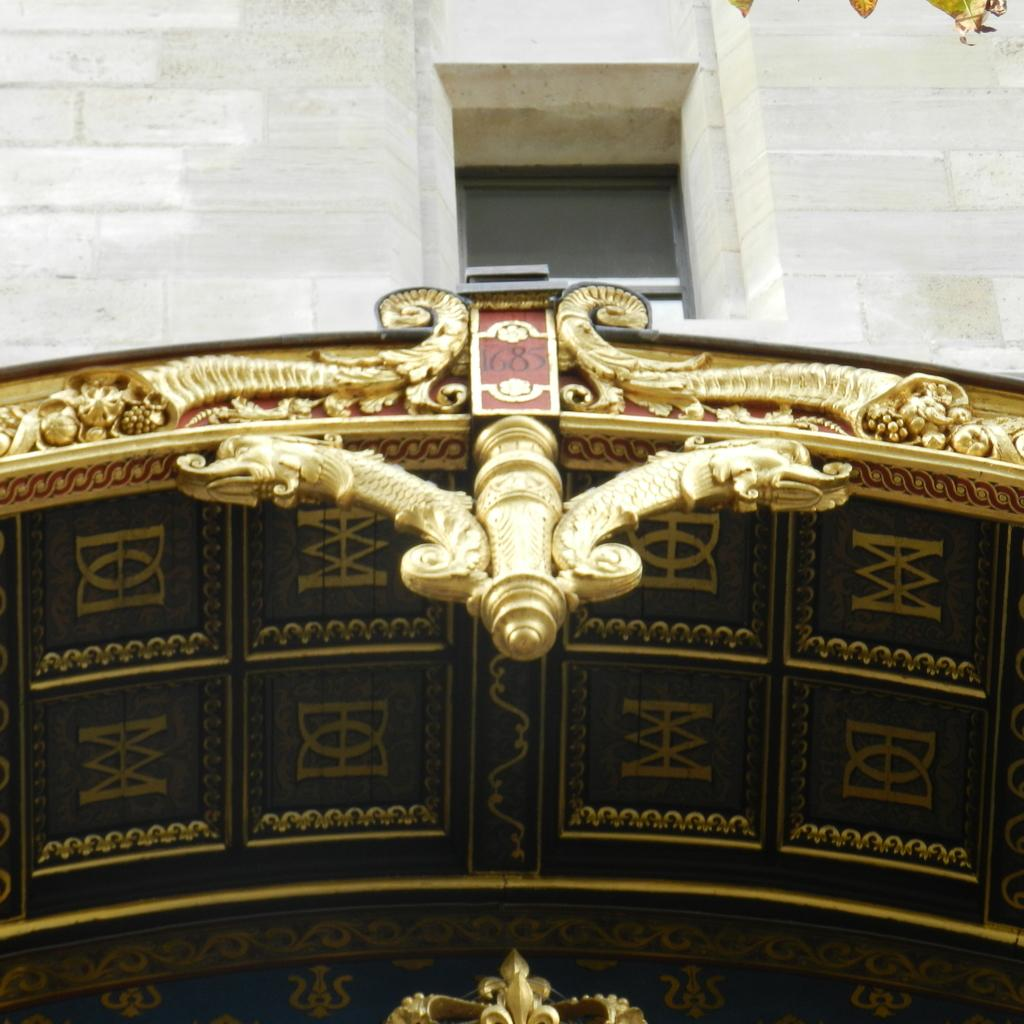What color is the ceiling in the image? The ceiling in the image is gold-colored. What is on the ceiling? There is a board on the ceiling. What is above the board on the ceiling? There is a wall above the board. Can you see any cows on the farm in the image? There is no farm or cows present in the image; it features a gold-colored ceiling with a board and a wall above it. 